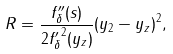<formula> <loc_0><loc_0><loc_500><loc_500>R = \frac { f ^ { \prime \prime } _ { \delta } ( s ) } { 2 { f ^ { \prime } _ { \delta } } ^ { 2 } ( y _ { z } ) } ( y _ { 2 } - y _ { z } ) ^ { 2 } ,</formula> 